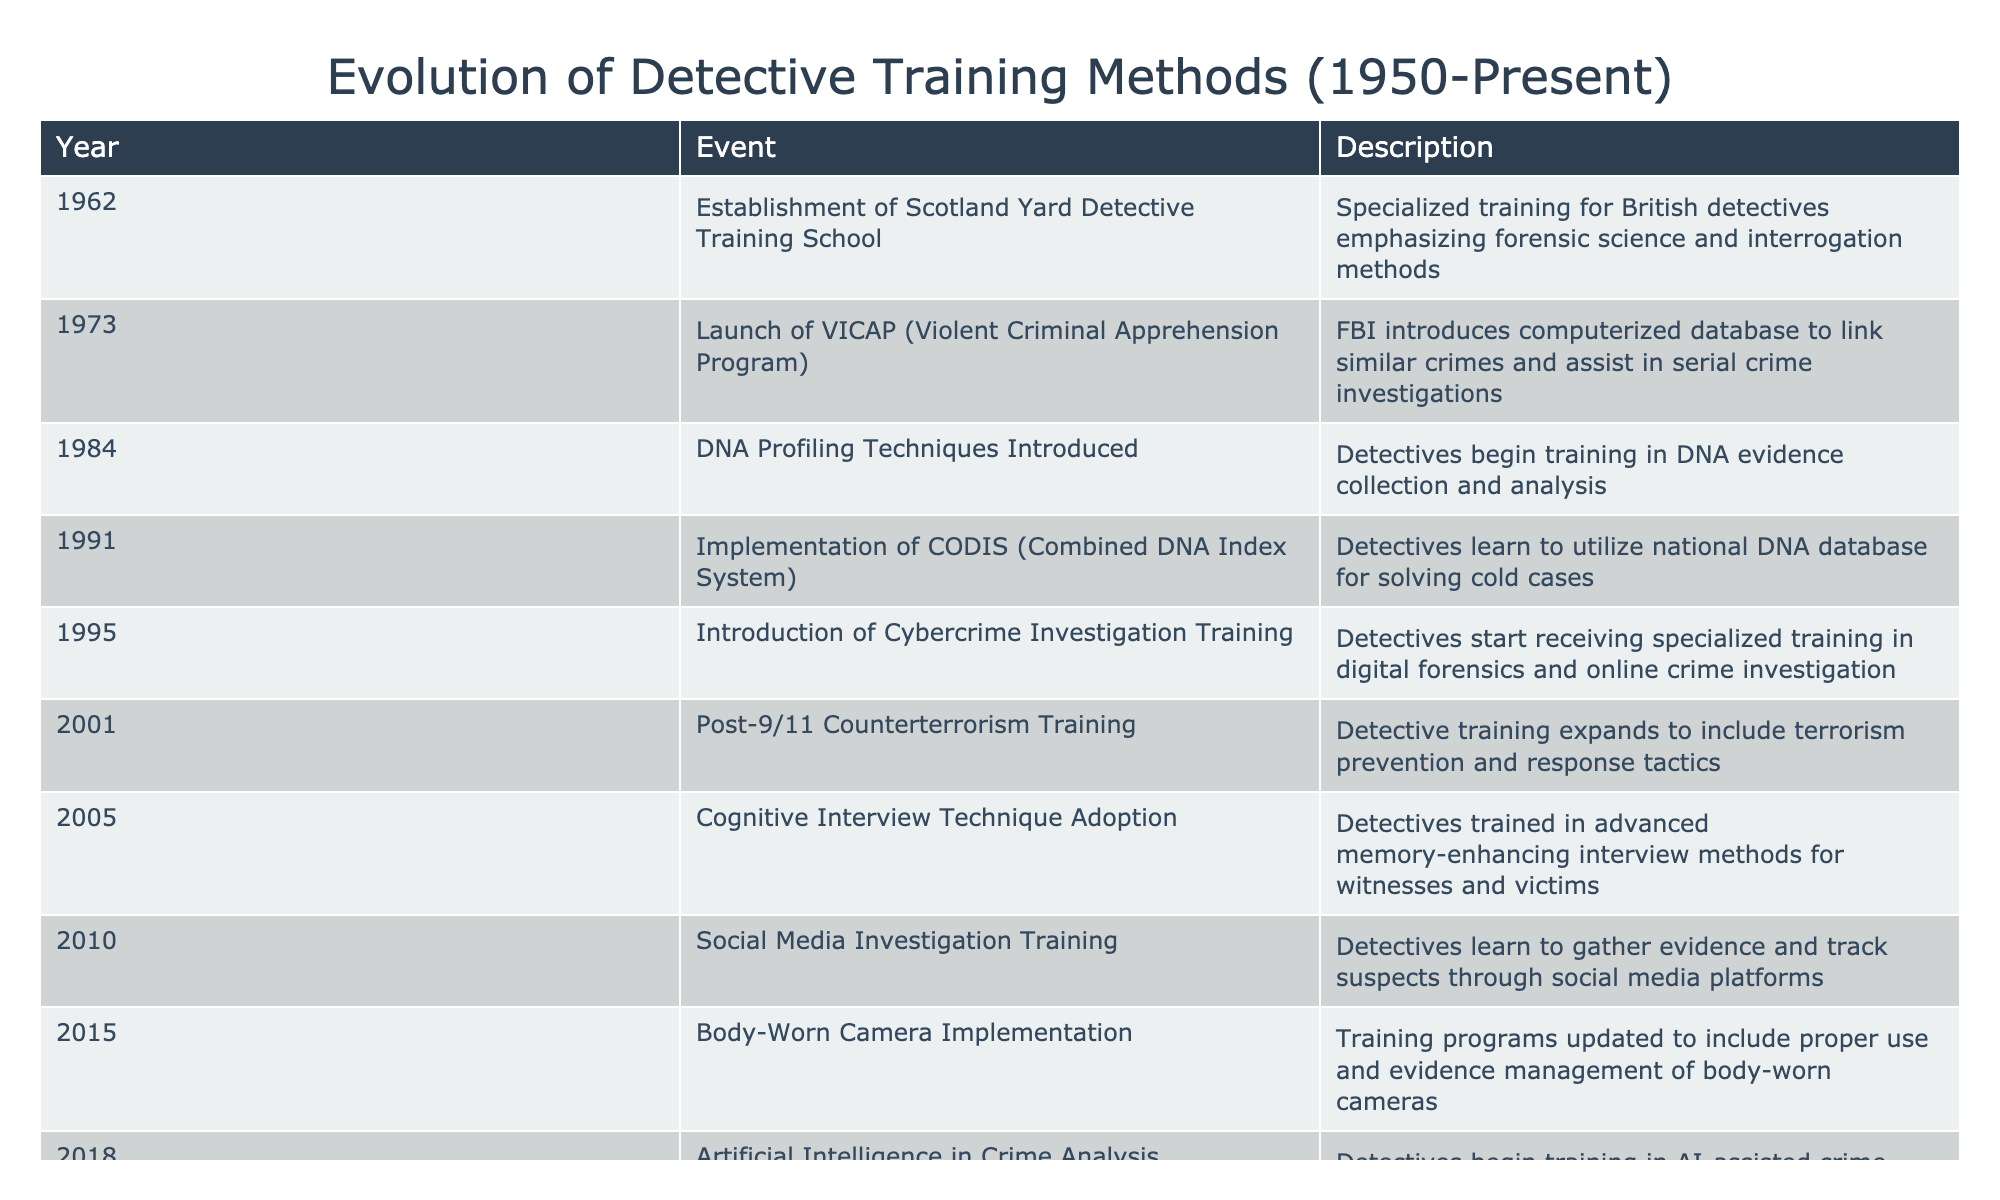What year was the establishment of the Scotland Yard Detective Training School? According to the table, the Scotland Yard Detective Training School was established in 1962.
Answer: 1962 Which training event introduced DNA profiling techniques? The table mentions that DNA profiling techniques were introduced in 1984.
Answer: 1984 How many key events occurred in the 2000s? Reviewing the events from the table, there are 6 key training events in the 2000s: 2001, 2005, 2010, 2015, and 2018.
Answer: 6 Was social media investigation training introduced before the implementation of body-worn cameras? The table shows that social media investigation training was introduced in 2010, while body-worn camera implementation took place in 2015. Hence, social media training was introduced before body-worn cameras.
Answer: Yes What is the total number of training methods introduced from 1962 to 2021? Counting the number of events listed from 1962 to 2021, we find 11 key training methods.
Answer: 11 In which year did detectives start receiving training in cybercrime investigation? The table states that detective training in cybercrime investigation began in 1995.
Answer: 1995 What was the most recent training method introduced in the table? The most recent event listed in the table is the introduction of Virtual Reality Crime Scene Training in 2021.
Answer: 2021 How did the focus of detective training change from 1962 to 2001? The table provides events indicating that the focus of detective training shifted from traditional detective skills, such as forensic science and interrogation methods in 1962, to include counterterrorism training due to the post-9/11 implications in 2001. Thus, there was a transition towards addressing newer types of crimes.
Answer: Shifted towards counterterrorism What training method was adopted in 2005? The table indicates that the Cognitive Interview Technique was adopted in 2005 for enhanced witness and victim interviews.
Answer: Cognitive Interview Technique 